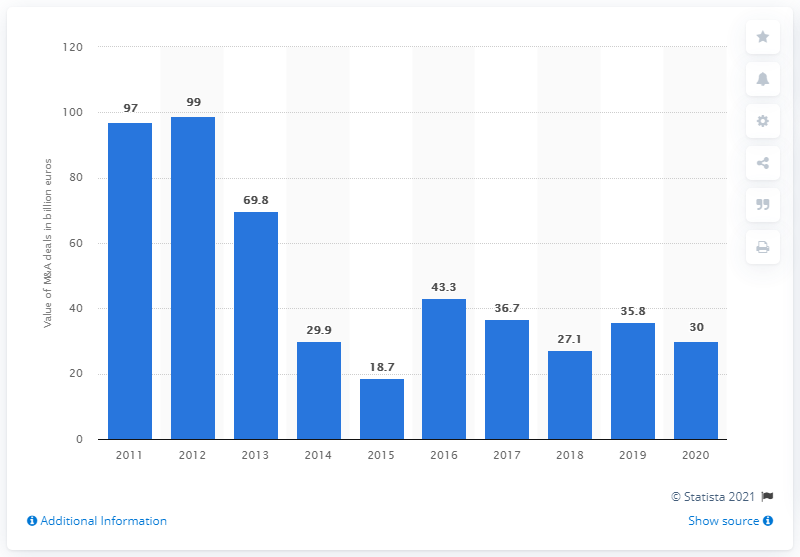Give some essential details in this illustration. The deal value in 2015 was 18.7. The total value of M&A transactions in Russia in 2020 was approximately 30 billion USD. 